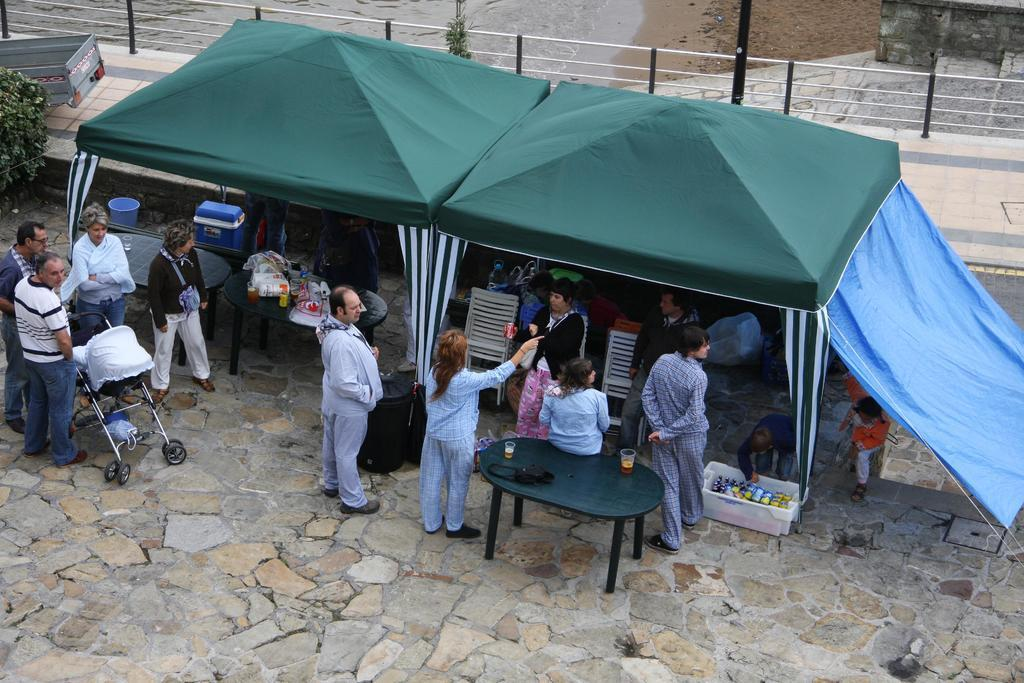How many people are in the image? There are multiple people in the image. What are the positions of the people in the image? One person is sitting on a table, while the rest of the people are standing. What type of vehicle is in the image? There is a vehicle in the image, but the specific type is not mentioned. What kind of plant is visible in the image? There is a tree in the image. What objects are present for carrying or holding items? There are baskets in the image. What type of furniture is in the image? There are chairs in the image. What type of shelter is in the image? There is a tent in the image. What arithmetic problem is being solved by the person sitting on the table? There is no indication in the image that a person is solving an arithmetic problem. How many fingers can be seen on the person standing next to the tree? The number of fingers on a person cannot be determined from the image, as it does not show only show the person's body from the waist up. 